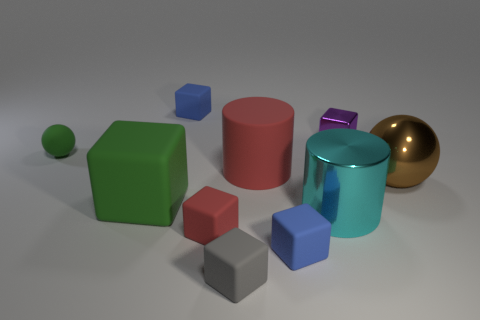What shape is the tiny gray matte thing that is to the right of the red thing in front of the large shiny ball?
Offer a terse response. Cube. Is there anything else of the same color as the big sphere?
Make the answer very short. No. Are there any other things that have the same size as the red rubber cylinder?
Provide a short and direct response. Yes. What number of objects are either large cyan cylinders or blue matte blocks?
Ensure brevity in your answer.  3. Are there any other red cubes of the same size as the shiny block?
Provide a short and direct response. Yes. There is a large cyan object; what shape is it?
Provide a short and direct response. Cylinder. Are there more tiny green balls that are behind the purple thing than green matte things behind the big green thing?
Provide a succinct answer. No. Does the metal object that is in front of the big metallic ball have the same color as the large matte object that is in front of the brown thing?
Your answer should be compact. No. What shape is the red rubber object that is the same size as the gray matte object?
Provide a succinct answer. Cube. Is there a large red object of the same shape as the small purple metallic object?
Offer a terse response. No. 